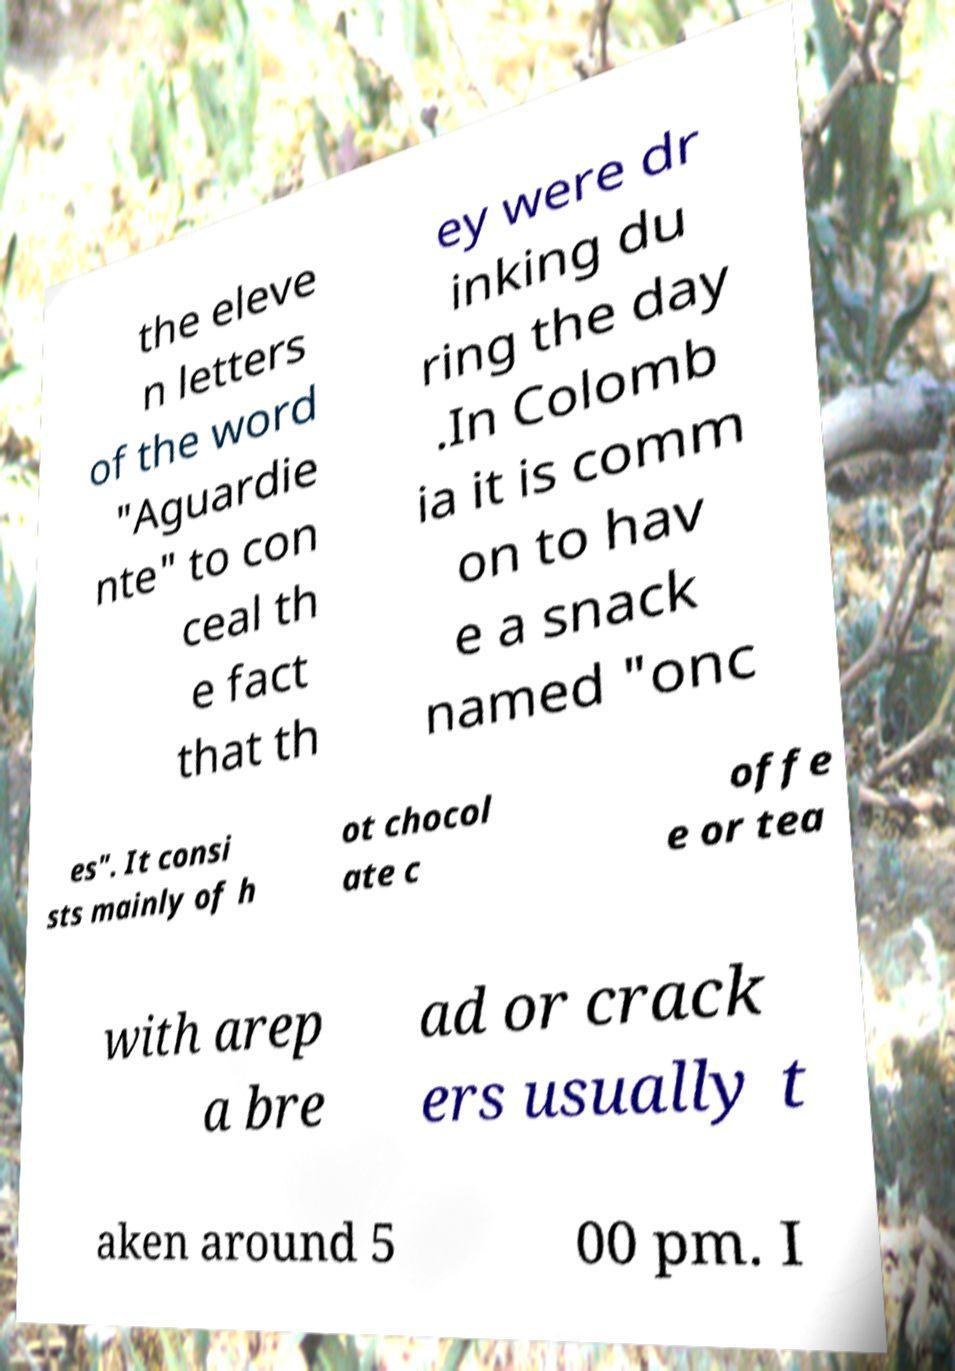Can you accurately transcribe the text from the provided image for me? the eleve n letters of the word "Aguardie nte" to con ceal th e fact that th ey were dr inking du ring the day .In Colomb ia it is comm on to hav e a snack named "onc es". It consi sts mainly of h ot chocol ate c offe e or tea with arep a bre ad or crack ers usually t aken around 5 00 pm. I 